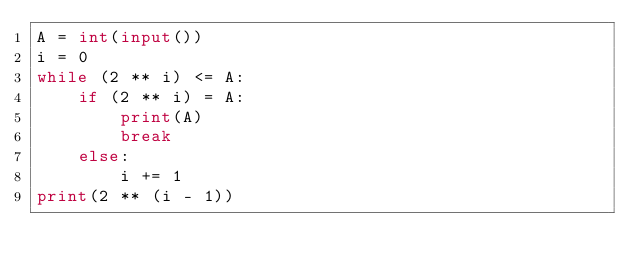Convert code to text. <code><loc_0><loc_0><loc_500><loc_500><_Python_>A = int(input())
i = 0
while (2 ** i) <= A:
    if (2 ** i) = A:
        print(A)
        break
    else:
        i += 1
print(2 ** (i - 1))</code> 